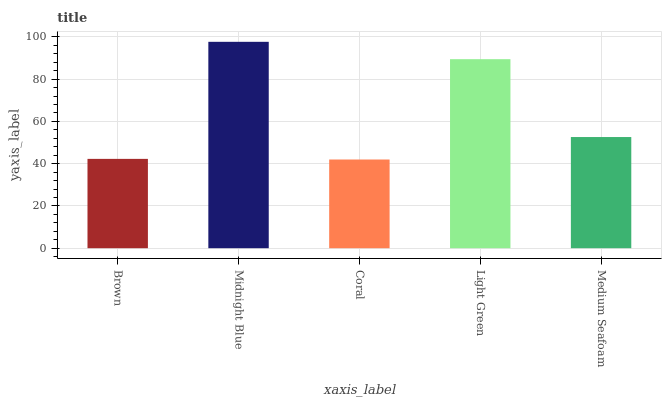Is Coral the minimum?
Answer yes or no. Yes. Is Midnight Blue the maximum?
Answer yes or no. Yes. Is Midnight Blue the minimum?
Answer yes or no. No. Is Coral the maximum?
Answer yes or no. No. Is Midnight Blue greater than Coral?
Answer yes or no. Yes. Is Coral less than Midnight Blue?
Answer yes or no. Yes. Is Coral greater than Midnight Blue?
Answer yes or no. No. Is Midnight Blue less than Coral?
Answer yes or no. No. Is Medium Seafoam the high median?
Answer yes or no. Yes. Is Medium Seafoam the low median?
Answer yes or no. Yes. Is Light Green the high median?
Answer yes or no. No. Is Brown the low median?
Answer yes or no. No. 